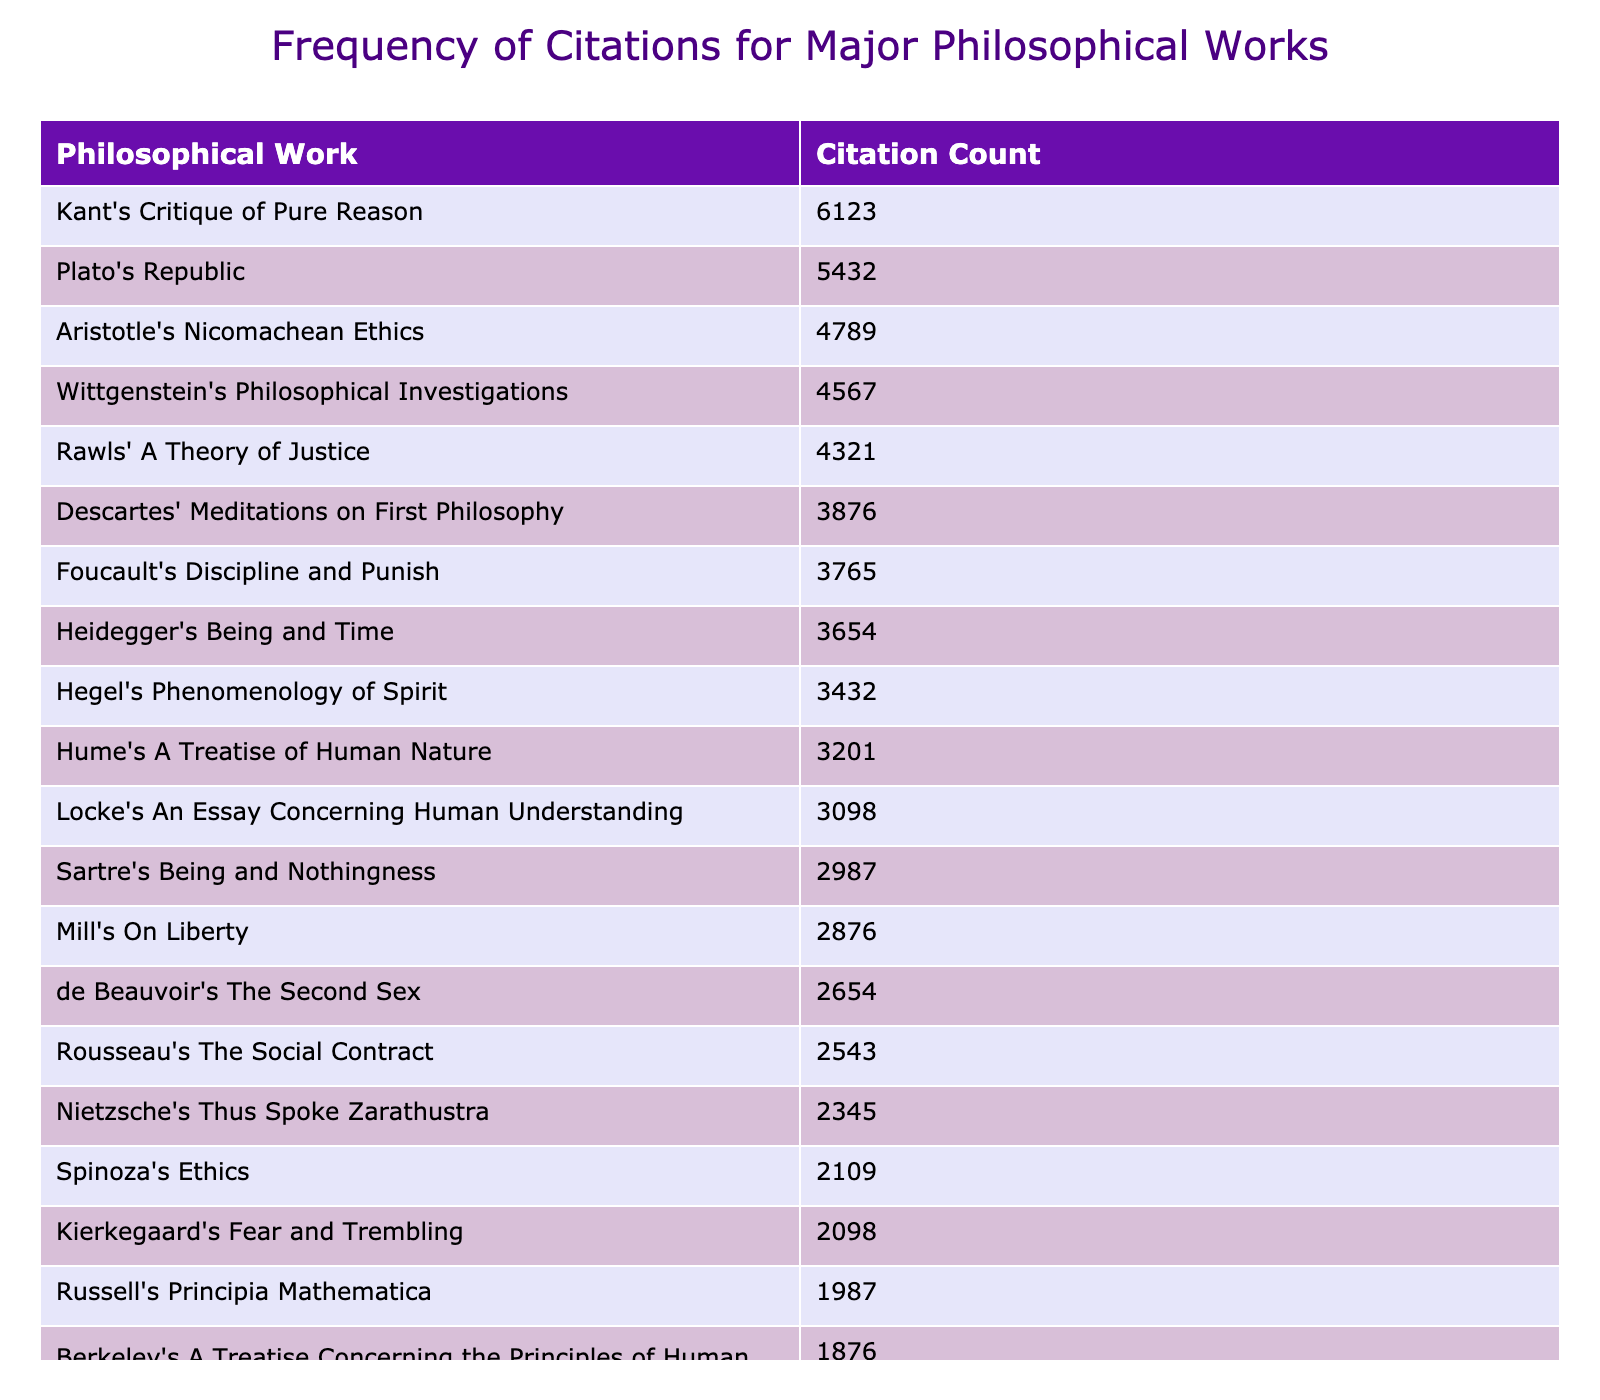What is the citation count for Kant's Critique of Pure Reason? The table lists the citation count for each philosophical work. By locating "Kant's Critique of Pure Reason," I find its citation count is 6123.
Answer: 6123 Which philosophical work has the highest citation count? The table is sorted in descending order by citation count. The first entry, "Kant's Critique of Pure Reason," has the highest citation count at 6123.
Answer: Kant's Critique of Pure Reason What is the difference in citation count between Aristotle's Nicomachean Ethics and Hume's A Treatise of Human Nature? The citation count for Aristotle's work is 4789, while for Hume's work, it is 3201. The difference is calculated as 4789 - 3201 = 1588.
Answer: 1588 How many philosophical works have a citation count above 4000? By checking the citation counts, I see that there are 4 works (Kant's Critique of Pure Reason, Plato's Republic, Rawls' A Theory of Justice, and Aristotle's Nicomachean Ethics) with citation counts above 4000.
Answer: 4 What is the average citation count for the works authored by Hume, Sartre, and Nietzsche? First, I find the citation counts: Hume (3201), Sartre (2987), and Nietzsche (2345). The sum is 3201 + 2987 + 2345 = 8533, and there are 3 works. The average is 8533 / 3 = 2844.33.
Answer: 2844.33 Is the citation count for Wittgenstein's Philosophical Investigations greater than that of Rousseau's The Social Contract? The citation count for Wittgenstein is 4567 and for Rousseau is 2543. Since 4567 is greater than 2543, the answer is yes.
Answer: Yes What percentage of the total citations is attributed to Plato's Republic? The citation count for Plato's Republic is 5432. First, I sum all citation counts, which is 43586. The percentage is (5432 / 43586) * 100 = 12.45%.
Answer: 12.45% How does the citation count of de Beauvoir's The Second Sex compare to that of Russell's Principia Mathematica? The citation count for de Beauvoir's work is 2654, while for Russell's work, it is 1987. Since 2654 is greater than 1987, it can be concluded that de Beauvoir's work has a higher citation count.
Answer: Higher Which philosophical work has a citation count that is less than 3000? I assess the table for works under 3000 citations. The works under this threshold are Sartre's Being and Nothingness (2987), and Nietzsche's Thus Spoke Zarathustra (2345), among others.
Answer: Sartre's Being and Nothingness, Nietzsche's Thus Spoke Zarathustra, and others 